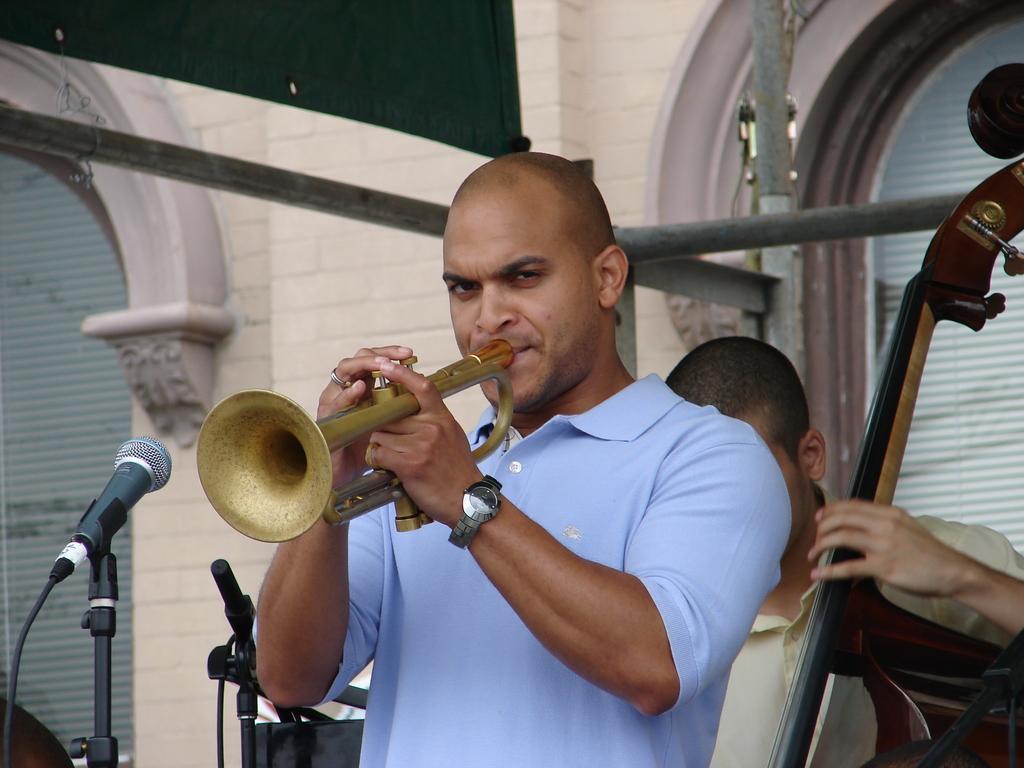Can you describe this image briefly? In this image there is a person standing and holding a trumpet, and at the background there is another person standing and holding a musical instrument , mics with the mike stands, building. 